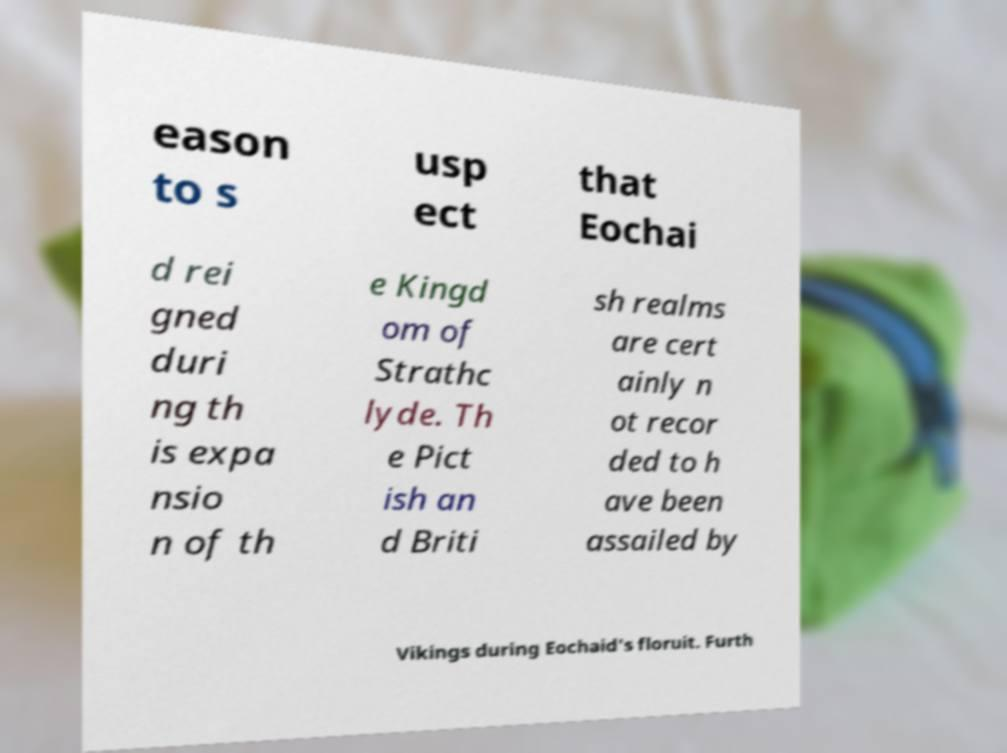Could you extract and type out the text from this image? eason to s usp ect that Eochai d rei gned duri ng th is expa nsio n of th e Kingd om of Strathc lyde. Th e Pict ish an d Briti sh realms are cert ainly n ot recor ded to h ave been assailed by Vikings during Eochaid's floruit. Furth 